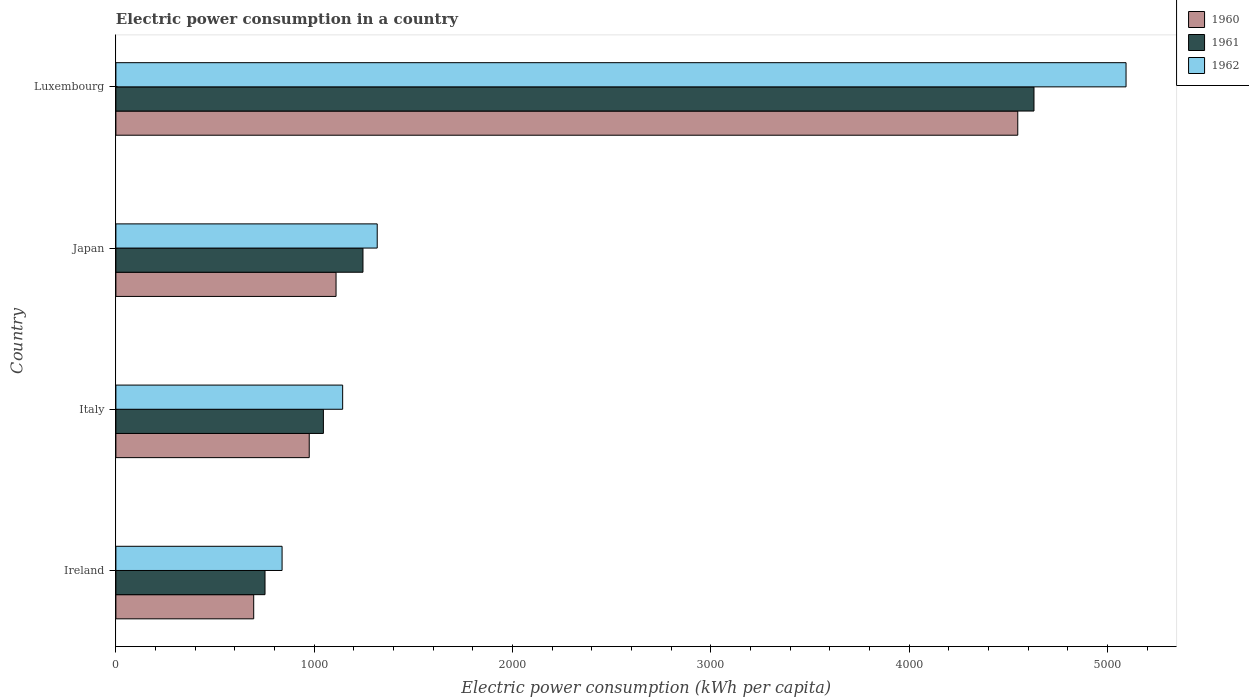Are the number of bars on each tick of the Y-axis equal?
Make the answer very short. Yes. What is the label of the 4th group of bars from the top?
Make the answer very short. Ireland. What is the electric power consumption in in 1960 in Luxembourg?
Provide a succinct answer. 4548.21. Across all countries, what is the maximum electric power consumption in in 1961?
Your response must be concise. 4630.02. Across all countries, what is the minimum electric power consumption in in 1961?
Your response must be concise. 752.02. In which country was the electric power consumption in in 1961 maximum?
Your answer should be very brief. Luxembourg. In which country was the electric power consumption in in 1962 minimum?
Your answer should be very brief. Ireland. What is the total electric power consumption in in 1960 in the graph?
Provide a succinct answer. 7328.54. What is the difference between the electric power consumption in in 1960 in Italy and that in Japan?
Offer a terse response. -135.24. What is the difference between the electric power consumption in in 1960 in Italy and the electric power consumption in in 1961 in Japan?
Your answer should be compact. -270.99. What is the average electric power consumption in in 1960 per country?
Your response must be concise. 1832.13. What is the difference between the electric power consumption in in 1961 and electric power consumption in in 1960 in Italy?
Your answer should be very brief. 71.39. What is the ratio of the electric power consumption in in 1960 in Italy to that in Luxembourg?
Make the answer very short. 0.21. Is the electric power consumption in in 1961 in Italy less than that in Luxembourg?
Your answer should be compact. Yes. Is the difference between the electric power consumption in in 1961 in Ireland and Japan greater than the difference between the electric power consumption in in 1960 in Ireland and Japan?
Offer a very short reply. No. What is the difference between the highest and the second highest electric power consumption in in 1962?
Make the answer very short. 3776.38. What is the difference between the highest and the lowest electric power consumption in in 1962?
Your answer should be very brief. 4256.17. Is the sum of the electric power consumption in in 1961 in Ireland and Luxembourg greater than the maximum electric power consumption in in 1962 across all countries?
Your answer should be very brief. Yes. What does the 1st bar from the top in Ireland represents?
Offer a very short reply. 1962. What does the 3rd bar from the bottom in Ireland represents?
Offer a terse response. 1962. How many legend labels are there?
Your answer should be very brief. 3. What is the title of the graph?
Provide a short and direct response. Electric power consumption in a country. Does "1998" appear as one of the legend labels in the graph?
Keep it short and to the point. No. What is the label or title of the X-axis?
Offer a very short reply. Electric power consumption (kWh per capita). What is the Electric power consumption (kWh per capita) of 1960 in Ireland?
Make the answer very short. 695.04. What is the Electric power consumption (kWh per capita) of 1961 in Ireland?
Ensure brevity in your answer.  752.02. What is the Electric power consumption (kWh per capita) in 1962 in Ireland?
Make the answer very short. 838.14. What is the Electric power consumption (kWh per capita) of 1960 in Italy?
Ensure brevity in your answer.  975.03. What is the Electric power consumption (kWh per capita) in 1961 in Italy?
Your response must be concise. 1046.42. What is the Electric power consumption (kWh per capita) of 1962 in Italy?
Provide a succinct answer. 1143.61. What is the Electric power consumption (kWh per capita) of 1960 in Japan?
Keep it short and to the point. 1110.26. What is the Electric power consumption (kWh per capita) in 1961 in Japan?
Keep it short and to the point. 1246.01. What is the Electric power consumption (kWh per capita) in 1962 in Japan?
Keep it short and to the point. 1317.93. What is the Electric power consumption (kWh per capita) of 1960 in Luxembourg?
Provide a succinct answer. 4548.21. What is the Electric power consumption (kWh per capita) of 1961 in Luxembourg?
Ensure brevity in your answer.  4630.02. What is the Electric power consumption (kWh per capita) of 1962 in Luxembourg?
Your answer should be compact. 5094.31. Across all countries, what is the maximum Electric power consumption (kWh per capita) in 1960?
Your answer should be compact. 4548.21. Across all countries, what is the maximum Electric power consumption (kWh per capita) in 1961?
Provide a short and direct response. 4630.02. Across all countries, what is the maximum Electric power consumption (kWh per capita) of 1962?
Offer a terse response. 5094.31. Across all countries, what is the minimum Electric power consumption (kWh per capita) of 1960?
Make the answer very short. 695.04. Across all countries, what is the minimum Electric power consumption (kWh per capita) of 1961?
Give a very brief answer. 752.02. Across all countries, what is the minimum Electric power consumption (kWh per capita) in 1962?
Provide a short and direct response. 838.14. What is the total Electric power consumption (kWh per capita) of 1960 in the graph?
Keep it short and to the point. 7328.54. What is the total Electric power consumption (kWh per capita) in 1961 in the graph?
Make the answer very short. 7674.47. What is the total Electric power consumption (kWh per capita) in 1962 in the graph?
Keep it short and to the point. 8393.98. What is the difference between the Electric power consumption (kWh per capita) in 1960 in Ireland and that in Italy?
Your answer should be very brief. -279.98. What is the difference between the Electric power consumption (kWh per capita) in 1961 in Ireland and that in Italy?
Give a very brief answer. -294.4. What is the difference between the Electric power consumption (kWh per capita) of 1962 in Ireland and that in Italy?
Offer a very short reply. -305.47. What is the difference between the Electric power consumption (kWh per capita) in 1960 in Ireland and that in Japan?
Provide a succinct answer. -415.22. What is the difference between the Electric power consumption (kWh per capita) of 1961 in Ireland and that in Japan?
Offer a very short reply. -493.99. What is the difference between the Electric power consumption (kWh per capita) in 1962 in Ireland and that in Japan?
Make the answer very short. -479.79. What is the difference between the Electric power consumption (kWh per capita) of 1960 in Ireland and that in Luxembourg?
Offer a very short reply. -3853.16. What is the difference between the Electric power consumption (kWh per capita) in 1961 in Ireland and that in Luxembourg?
Offer a terse response. -3878.01. What is the difference between the Electric power consumption (kWh per capita) in 1962 in Ireland and that in Luxembourg?
Offer a terse response. -4256.17. What is the difference between the Electric power consumption (kWh per capita) of 1960 in Italy and that in Japan?
Keep it short and to the point. -135.24. What is the difference between the Electric power consumption (kWh per capita) in 1961 in Italy and that in Japan?
Your answer should be compact. -199.6. What is the difference between the Electric power consumption (kWh per capita) in 1962 in Italy and that in Japan?
Make the answer very short. -174.33. What is the difference between the Electric power consumption (kWh per capita) of 1960 in Italy and that in Luxembourg?
Your answer should be very brief. -3573.18. What is the difference between the Electric power consumption (kWh per capita) in 1961 in Italy and that in Luxembourg?
Your answer should be very brief. -3583.61. What is the difference between the Electric power consumption (kWh per capita) of 1962 in Italy and that in Luxembourg?
Give a very brief answer. -3950.71. What is the difference between the Electric power consumption (kWh per capita) in 1960 in Japan and that in Luxembourg?
Ensure brevity in your answer.  -3437.94. What is the difference between the Electric power consumption (kWh per capita) in 1961 in Japan and that in Luxembourg?
Give a very brief answer. -3384.01. What is the difference between the Electric power consumption (kWh per capita) in 1962 in Japan and that in Luxembourg?
Make the answer very short. -3776.38. What is the difference between the Electric power consumption (kWh per capita) in 1960 in Ireland and the Electric power consumption (kWh per capita) in 1961 in Italy?
Provide a succinct answer. -351.37. What is the difference between the Electric power consumption (kWh per capita) in 1960 in Ireland and the Electric power consumption (kWh per capita) in 1962 in Italy?
Ensure brevity in your answer.  -448.56. What is the difference between the Electric power consumption (kWh per capita) in 1961 in Ireland and the Electric power consumption (kWh per capita) in 1962 in Italy?
Keep it short and to the point. -391.59. What is the difference between the Electric power consumption (kWh per capita) of 1960 in Ireland and the Electric power consumption (kWh per capita) of 1961 in Japan?
Your response must be concise. -550.97. What is the difference between the Electric power consumption (kWh per capita) of 1960 in Ireland and the Electric power consumption (kWh per capita) of 1962 in Japan?
Offer a very short reply. -622.89. What is the difference between the Electric power consumption (kWh per capita) in 1961 in Ireland and the Electric power consumption (kWh per capita) in 1962 in Japan?
Offer a very short reply. -565.91. What is the difference between the Electric power consumption (kWh per capita) in 1960 in Ireland and the Electric power consumption (kWh per capita) in 1961 in Luxembourg?
Your response must be concise. -3934.98. What is the difference between the Electric power consumption (kWh per capita) in 1960 in Ireland and the Electric power consumption (kWh per capita) in 1962 in Luxembourg?
Give a very brief answer. -4399.27. What is the difference between the Electric power consumption (kWh per capita) of 1961 in Ireland and the Electric power consumption (kWh per capita) of 1962 in Luxembourg?
Make the answer very short. -4342.29. What is the difference between the Electric power consumption (kWh per capita) in 1960 in Italy and the Electric power consumption (kWh per capita) in 1961 in Japan?
Your response must be concise. -270.99. What is the difference between the Electric power consumption (kWh per capita) of 1960 in Italy and the Electric power consumption (kWh per capita) of 1962 in Japan?
Ensure brevity in your answer.  -342.91. What is the difference between the Electric power consumption (kWh per capita) in 1961 in Italy and the Electric power consumption (kWh per capita) in 1962 in Japan?
Offer a very short reply. -271.52. What is the difference between the Electric power consumption (kWh per capita) of 1960 in Italy and the Electric power consumption (kWh per capita) of 1961 in Luxembourg?
Provide a succinct answer. -3655. What is the difference between the Electric power consumption (kWh per capita) in 1960 in Italy and the Electric power consumption (kWh per capita) in 1962 in Luxembourg?
Your answer should be very brief. -4119.28. What is the difference between the Electric power consumption (kWh per capita) of 1961 in Italy and the Electric power consumption (kWh per capita) of 1962 in Luxembourg?
Offer a terse response. -4047.9. What is the difference between the Electric power consumption (kWh per capita) in 1960 in Japan and the Electric power consumption (kWh per capita) in 1961 in Luxembourg?
Keep it short and to the point. -3519.76. What is the difference between the Electric power consumption (kWh per capita) of 1960 in Japan and the Electric power consumption (kWh per capita) of 1962 in Luxembourg?
Make the answer very short. -3984.05. What is the difference between the Electric power consumption (kWh per capita) in 1961 in Japan and the Electric power consumption (kWh per capita) in 1962 in Luxembourg?
Give a very brief answer. -3848.3. What is the average Electric power consumption (kWh per capita) of 1960 per country?
Provide a succinct answer. 1832.13. What is the average Electric power consumption (kWh per capita) of 1961 per country?
Keep it short and to the point. 1918.62. What is the average Electric power consumption (kWh per capita) in 1962 per country?
Provide a succinct answer. 2098.5. What is the difference between the Electric power consumption (kWh per capita) in 1960 and Electric power consumption (kWh per capita) in 1961 in Ireland?
Offer a terse response. -56.97. What is the difference between the Electric power consumption (kWh per capita) in 1960 and Electric power consumption (kWh per capita) in 1962 in Ireland?
Give a very brief answer. -143.09. What is the difference between the Electric power consumption (kWh per capita) in 1961 and Electric power consumption (kWh per capita) in 1962 in Ireland?
Give a very brief answer. -86.12. What is the difference between the Electric power consumption (kWh per capita) of 1960 and Electric power consumption (kWh per capita) of 1961 in Italy?
Your answer should be compact. -71.39. What is the difference between the Electric power consumption (kWh per capita) of 1960 and Electric power consumption (kWh per capita) of 1962 in Italy?
Make the answer very short. -168.58. What is the difference between the Electric power consumption (kWh per capita) of 1961 and Electric power consumption (kWh per capita) of 1962 in Italy?
Your answer should be very brief. -97.19. What is the difference between the Electric power consumption (kWh per capita) of 1960 and Electric power consumption (kWh per capita) of 1961 in Japan?
Ensure brevity in your answer.  -135.75. What is the difference between the Electric power consumption (kWh per capita) in 1960 and Electric power consumption (kWh per capita) in 1962 in Japan?
Offer a terse response. -207.67. What is the difference between the Electric power consumption (kWh per capita) of 1961 and Electric power consumption (kWh per capita) of 1962 in Japan?
Keep it short and to the point. -71.92. What is the difference between the Electric power consumption (kWh per capita) in 1960 and Electric power consumption (kWh per capita) in 1961 in Luxembourg?
Ensure brevity in your answer.  -81.82. What is the difference between the Electric power consumption (kWh per capita) in 1960 and Electric power consumption (kWh per capita) in 1962 in Luxembourg?
Ensure brevity in your answer.  -546.11. What is the difference between the Electric power consumption (kWh per capita) of 1961 and Electric power consumption (kWh per capita) of 1962 in Luxembourg?
Keep it short and to the point. -464.29. What is the ratio of the Electric power consumption (kWh per capita) in 1960 in Ireland to that in Italy?
Offer a very short reply. 0.71. What is the ratio of the Electric power consumption (kWh per capita) in 1961 in Ireland to that in Italy?
Offer a terse response. 0.72. What is the ratio of the Electric power consumption (kWh per capita) of 1962 in Ireland to that in Italy?
Your answer should be very brief. 0.73. What is the ratio of the Electric power consumption (kWh per capita) of 1960 in Ireland to that in Japan?
Your answer should be compact. 0.63. What is the ratio of the Electric power consumption (kWh per capita) in 1961 in Ireland to that in Japan?
Offer a terse response. 0.6. What is the ratio of the Electric power consumption (kWh per capita) of 1962 in Ireland to that in Japan?
Offer a very short reply. 0.64. What is the ratio of the Electric power consumption (kWh per capita) of 1960 in Ireland to that in Luxembourg?
Offer a terse response. 0.15. What is the ratio of the Electric power consumption (kWh per capita) of 1961 in Ireland to that in Luxembourg?
Give a very brief answer. 0.16. What is the ratio of the Electric power consumption (kWh per capita) in 1962 in Ireland to that in Luxembourg?
Make the answer very short. 0.16. What is the ratio of the Electric power consumption (kWh per capita) of 1960 in Italy to that in Japan?
Ensure brevity in your answer.  0.88. What is the ratio of the Electric power consumption (kWh per capita) in 1961 in Italy to that in Japan?
Offer a terse response. 0.84. What is the ratio of the Electric power consumption (kWh per capita) in 1962 in Italy to that in Japan?
Your answer should be very brief. 0.87. What is the ratio of the Electric power consumption (kWh per capita) in 1960 in Italy to that in Luxembourg?
Ensure brevity in your answer.  0.21. What is the ratio of the Electric power consumption (kWh per capita) of 1961 in Italy to that in Luxembourg?
Offer a terse response. 0.23. What is the ratio of the Electric power consumption (kWh per capita) in 1962 in Italy to that in Luxembourg?
Give a very brief answer. 0.22. What is the ratio of the Electric power consumption (kWh per capita) of 1960 in Japan to that in Luxembourg?
Ensure brevity in your answer.  0.24. What is the ratio of the Electric power consumption (kWh per capita) of 1961 in Japan to that in Luxembourg?
Keep it short and to the point. 0.27. What is the ratio of the Electric power consumption (kWh per capita) in 1962 in Japan to that in Luxembourg?
Provide a short and direct response. 0.26. What is the difference between the highest and the second highest Electric power consumption (kWh per capita) in 1960?
Keep it short and to the point. 3437.94. What is the difference between the highest and the second highest Electric power consumption (kWh per capita) of 1961?
Provide a succinct answer. 3384.01. What is the difference between the highest and the second highest Electric power consumption (kWh per capita) of 1962?
Keep it short and to the point. 3776.38. What is the difference between the highest and the lowest Electric power consumption (kWh per capita) in 1960?
Provide a succinct answer. 3853.16. What is the difference between the highest and the lowest Electric power consumption (kWh per capita) of 1961?
Make the answer very short. 3878.01. What is the difference between the highest and the lowest Electric power consumption (kWh per capita) in 1962?
Offer a terse response. 4256.17. 